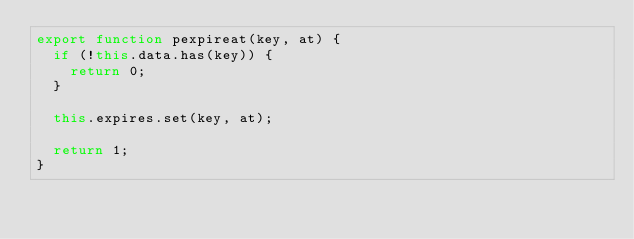<code> <loc_0><loc_0><loc_500><loc_500><_JavaScript_>export function pexpireat(key, at) {
  if (!this.data.has(key)) {
    return 0;
  }

  this.expires.set(key, at);

  return 1;
}
</code> 